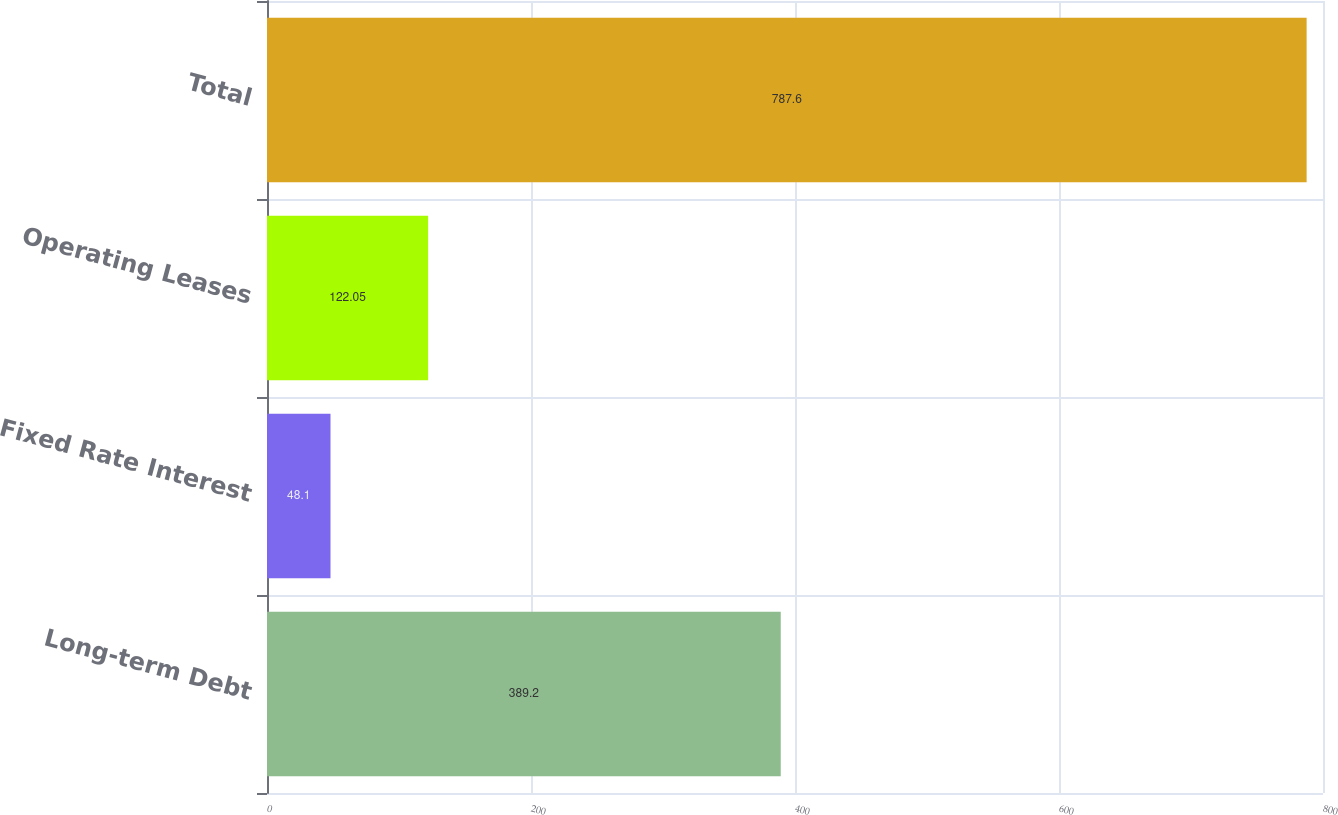<chart> <loc_0><loc_0><loc_500><loc_500><bar_chart><fcel>Long-term Debt<fcel>Fixed Rate Interest<fcel>Operating Leases<fcel>Total<nl><fcel>389.2<fcel>48.1<fcel>122.05<fcel>787.6<nl></chart> 